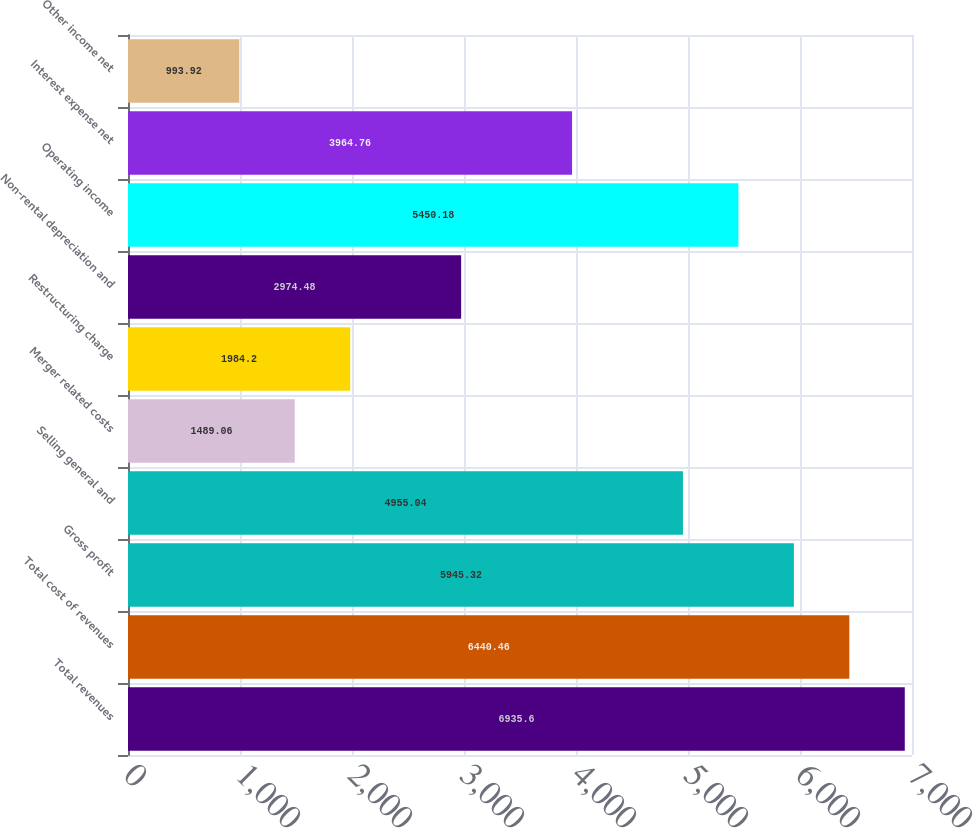Convert chart. <chart><loc_0><loc_0><loc_500><loc_500><bar_chart><fcel>Total revenues<fcel>Total cost of revenues<fcel>Gross profit<fcel>Selling general and<fcel>Merger related costs<fcel>Restructuring charge<fcel>Non-rental depreciation and<fcel>Operating income<fcel>Interest expense net<fcel>Other income net<nl><fcel>6935.6<fcel>6440.46<fcel>5945.32<fcel>4955.04<fcel>1489.06<fcel>1984.2<fcel>2974.48<fcel>5450.18<fcel>3964.76<fcel>993.92<nl></chart> 